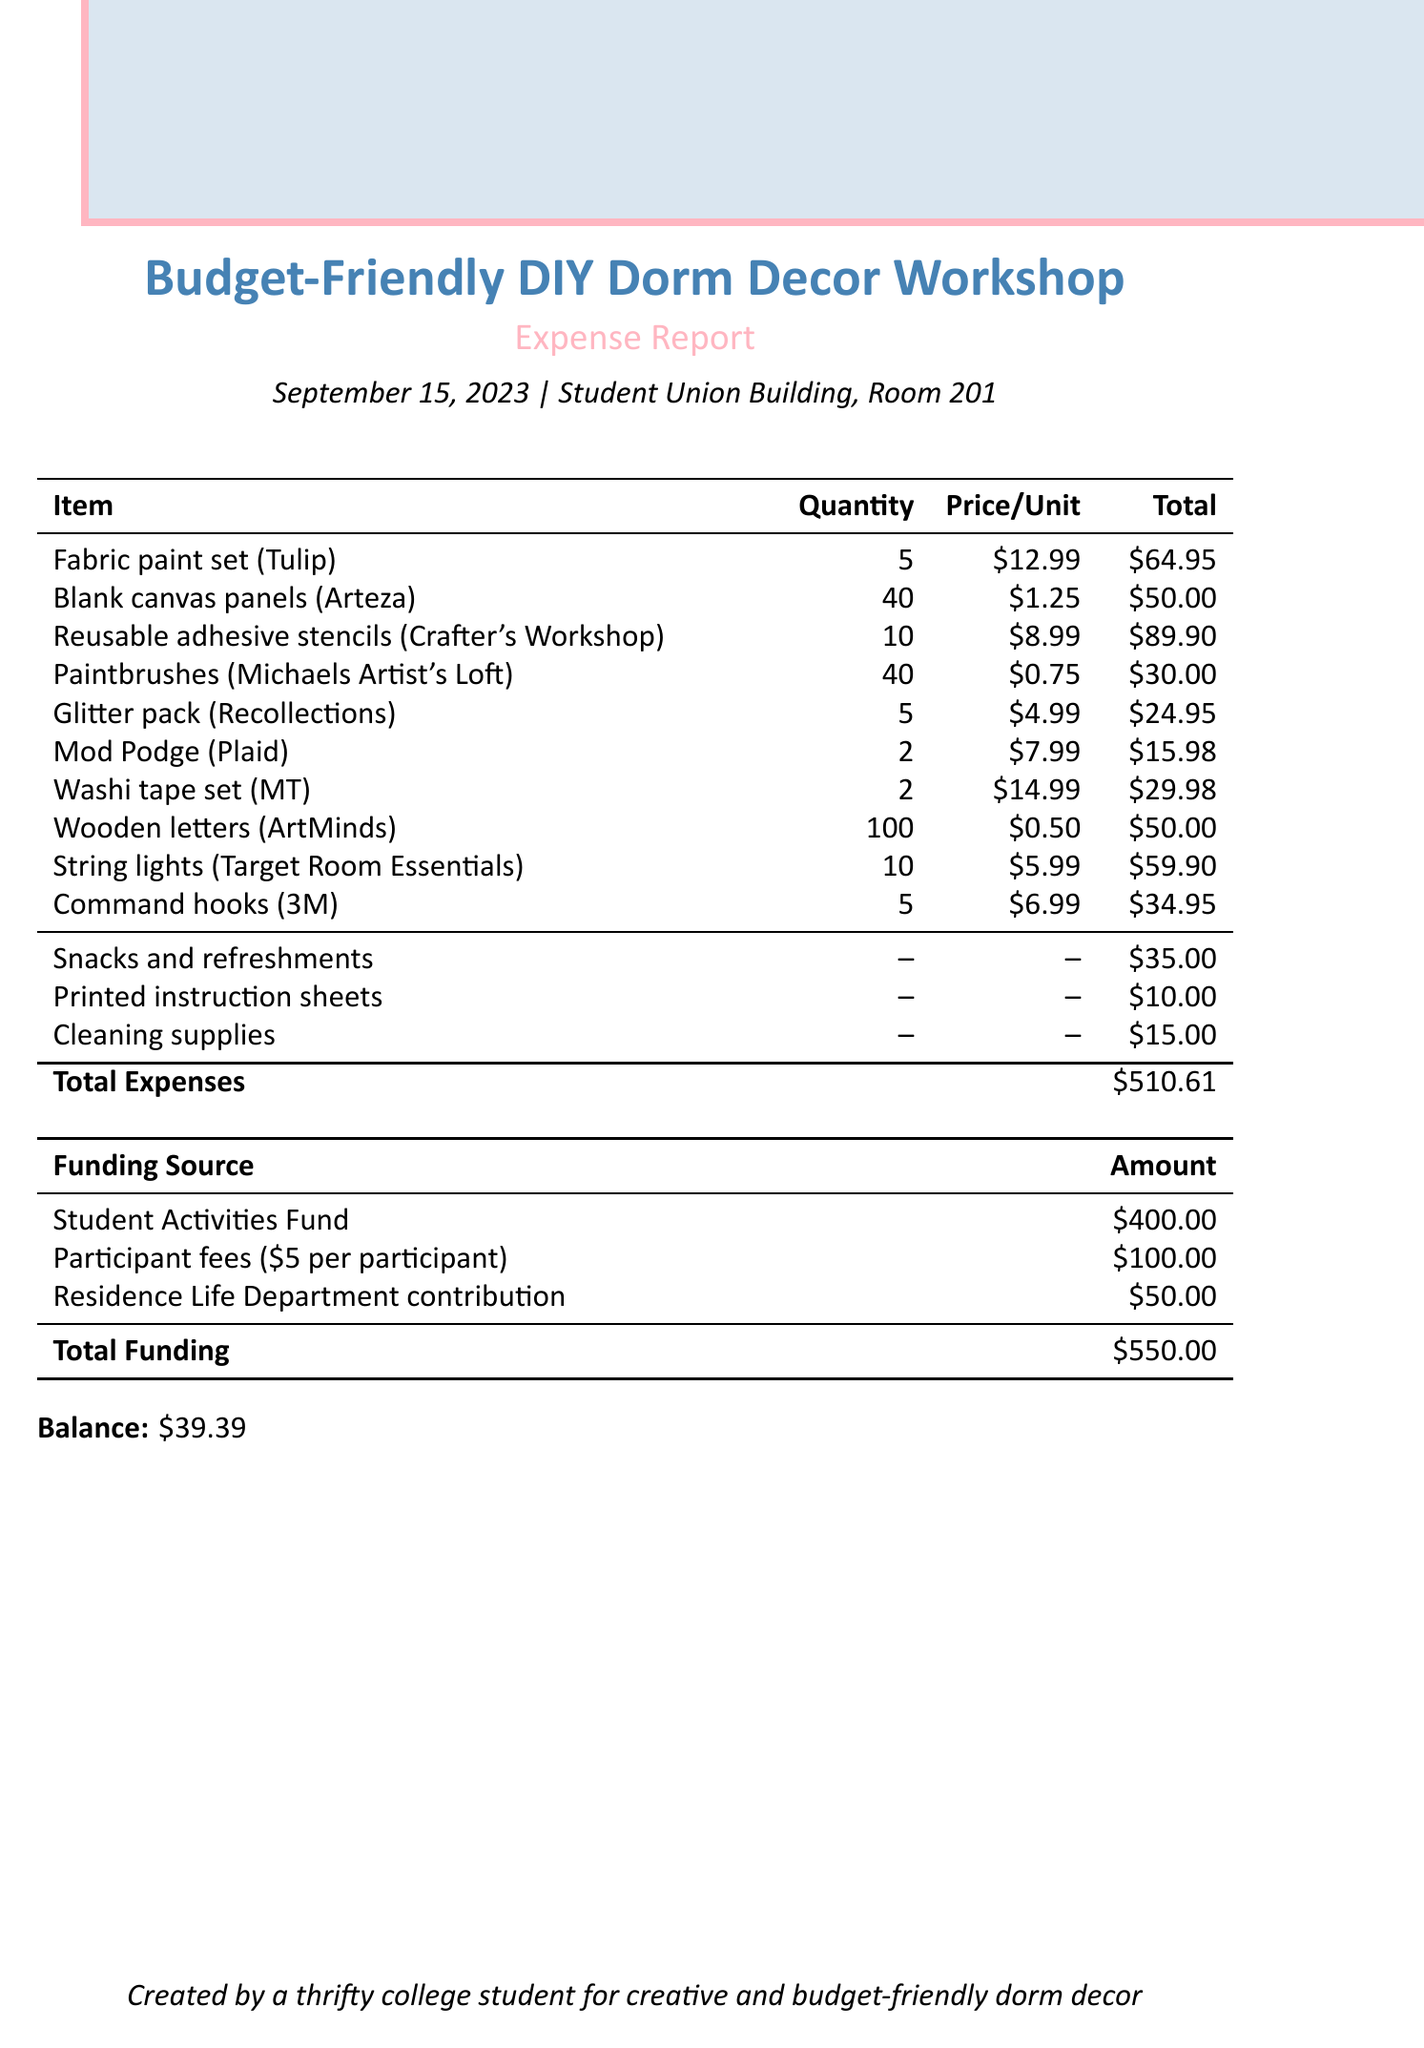What is the title of the workshop? The title of the workshop is located in the header section of the document, which is "Budget-Friendly DIY Dorm Decor Workshop."
Answer: Budget-Friendly DIY Dorm Decor Workshop What date was the workshop held? The date of the workshop is mentioned near the title, which states "September 15, 2023."
Answer: September 15, 2023 How many participants were there? The number of participants is found in the workshop details, specifically stating "20."
Answer: 20 What is the total cost of fabric paint? The total cost for fabric paint appears in the supplies list and is recorded as "$64.95."
Answer: $64.95 What is the quantity of blank canvas panels purchased? The quantity of blank canvas panels is specified in the supplies list, indicating "40."
Answer: 40 What are the total expenses incurred for the workshop? The total expenses are recorded at the bottom of the document as "$510.61."
Answer: $510.61 What is the total funding received for the workshop? The total funding is mentioned in the funding sources table as "$550.00."
Answer: $550.00 What is the balance remaining after expenses? The balance is noted at the end of the document as "$39.39."
Answer: $39.39 How much was spent on snacks and refreshments? The cost for snacks and refreshments is detailed in the additional expenses section as "$35.00."
Answer: $35.00 